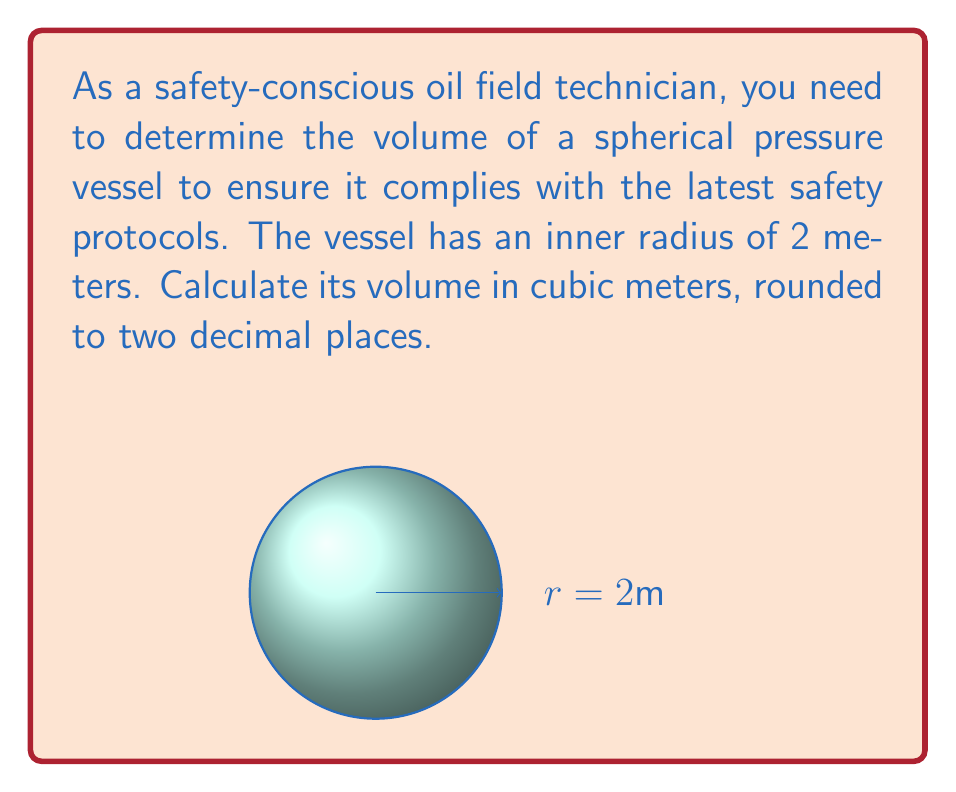Give your solution to this math problem. To determine the volume of a spherical pressure vessel, we use the formula for the volume of a sphere:

$$V = \frac{4}{3}\pi r^3$$

Where:
$V$ = volume of the sphere
$r$ = radius of the sphere

Given:
$r = 2$ meters

Let's substitute the value into the formula:

$$V = \frac{4}{3}\pi (2)^3$$

$$V = \frac{4}{3}\pi (8)$$

$$V = \frac{32}{3}\pi$$

Now, let's calculate this value:

$$V \approx 33.5103 \text{ m}^3$$

Rounding to two decimal places:

$$V \approx 33.51 \text{ m}^3$$
Answer: $33.51 \text{ m}^3$ 